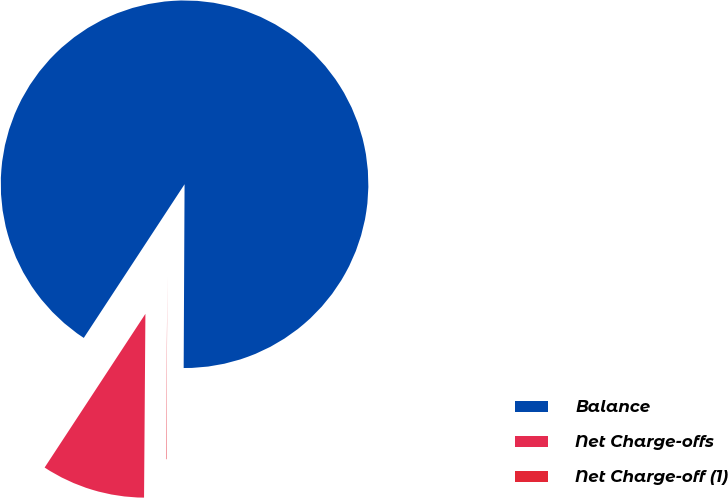Convert chart to OTSL. <chart><loc_0><loc_0><loc_500><loc_500><pie_chart><fcel>Balance<fcel>Net Charge-offs<fcel>Net Charge-off (1)<nl><fcel>90.83%<fcel>9.12%<fcel>0.04%<nl></chart> 